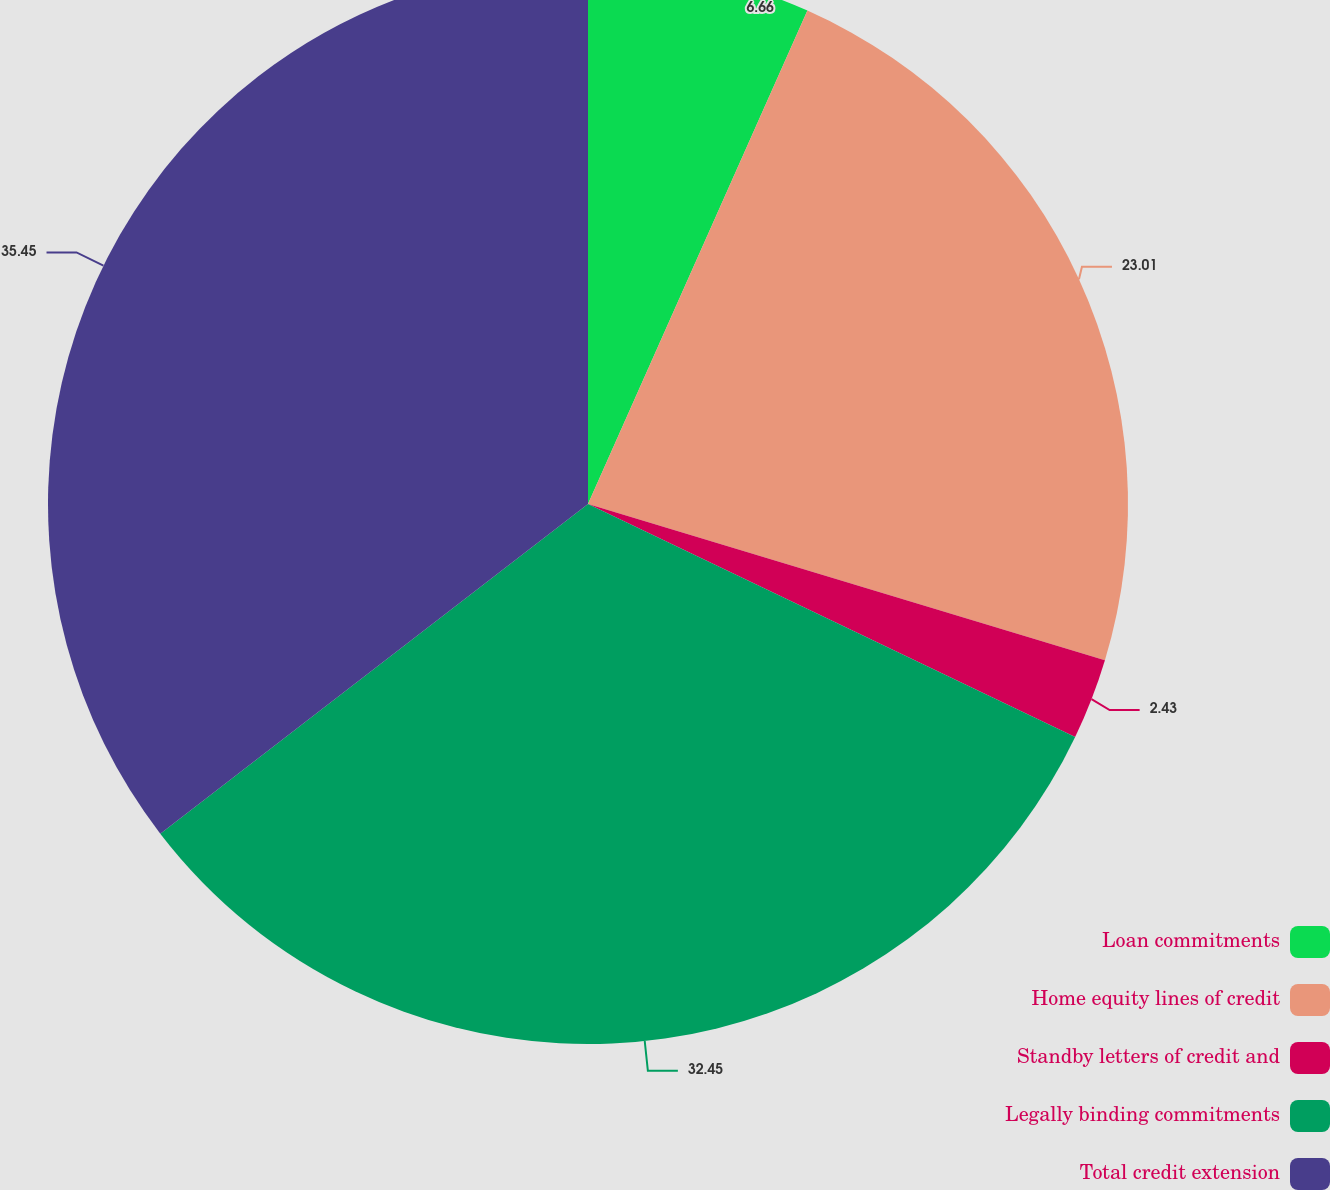<chart> <loc_0><loc_0><loc_500><loc_500><pie_chart><fcel>Loan commitments<fcel>Home equity lines of credit<fcel>Standby letters of credit and<fcel>Legally binding commitments<fcel>Total credit extension<nl><fcel>6.66%<fcel>23.01%<fcel>2.43%<fcel>32.45%<fcel>35.45%<nl></chart> 